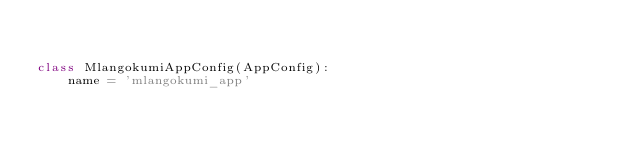Convert code to text. <code><loc_0><loc_0><loc_500><loc_500><_Python_>

class MlangokumiAppConfig(AppConfig):
    name = 'mlangokumi_app'
</code> 